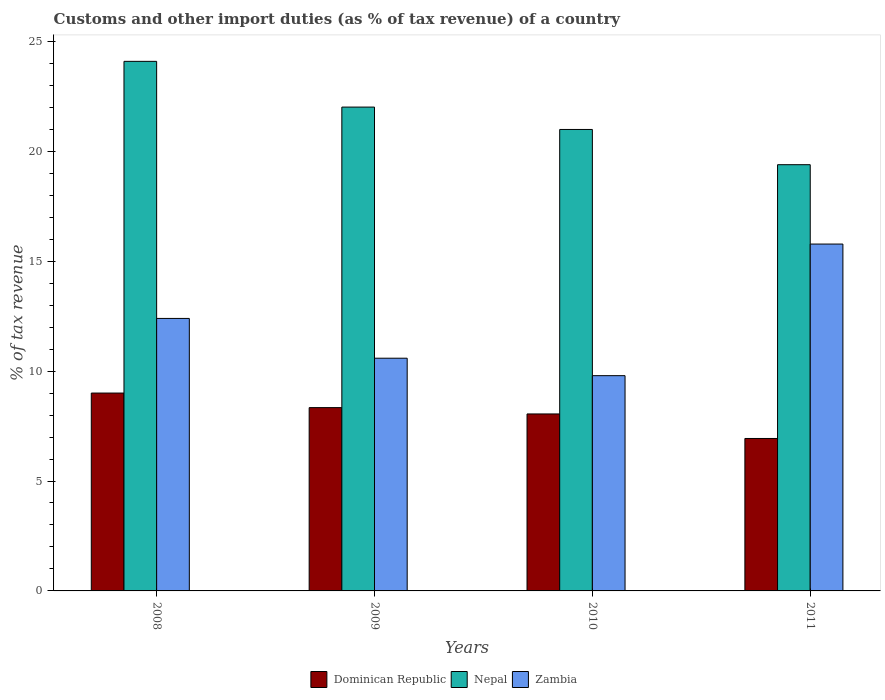How many different coloured bars are there?
Make the answer very short. 3. How many groups of bars are there?
Provide a succinct answer. 4. Are the number of bars per tick equal to the number of legend labels?
Keep it short and to the point. Yes. How many bars are there on the 1st tick from the right?
Provide a short and direct response. 3. What is the label of the 1st group of bars from the left?
Your answer should be compact. 2008. In how many cases, is the number of bars for a given year not equal to the number of legend labels?
Make the answer very short. 0. What is the percentage of tax revenue from customs in Zambia in 2009?
Give a very brief answer. 10.59. Across all years, what is the maximum percentage of tax revenue from customs in Zambia?
Your response must be concise. 15.78. Across all years, what is the minimum percentage of tax revenue from customs in Nepal?
Your answer should be compact. 19.39. In which year was the percentage of tax revenue from customs in Dominican Republic minimum?
Offer a terse response. 2011. What is the total percentage of tax revenue from customs in Nepal in the graph?
Provide a succinct answer. 86.49. What is the difference between the percentage of tax revenue from customs in Nepal in 2009 and that in 2010?
Your answer should be compact. 1.02. What is the difference between the percentage of tax revenue from customs in Zambia in 2011 and the percentage of tax revenue from customs in Dominican Republic in 2010?
Ensure brevity in your answer.  7.73. What is the average percentage of tax revenue from customs in Dominican Republic per year?
Your response must be concise. 8.08. In the year 2011, what is the difference between the percentage of tax revenue from customs in Zambia and percentage of tax revenue from customs in Nepal?
Offer a terse response. -3.61. In how many years, is the percentage of tax revenue from customs in Dominican Republic greater than 21 %?
Provide a short and direct response. 0. What is the ratio of the percentage of tax revenue from customs in Zambia in 2008 to that in 2009?
Your answer should be very brief. 1.17. Is the difference between the percentage of tax revenue from customs in Zambia in 2008 and 2010 greater than the difference between the percentage of tax revenue from customs in Nepal in 2008 and 2010?
Provide a succinct answer. No. What is the difference between the highest and the second highest percentage of tax revenue from customs in Dominican Republic?
Provide a short and direct response. 0.66. What is the difference between the highest and the lowest percentage of tax revenue from customs in Nepal?
Your response must be concise. 4.7. Is the sum of the percentage of tax revenue from customs in Zambia in 2009 and 2010 greater than the maximum percentage of tax revenue from customs in Dominican Republic across all years?
Make the answer very short. Yes. What does the 3rd bar from the left in 2009 represents?
Ensure brevity in your answer.  Zambia. What does the 3rd bar from the right in 2011 represents?
Offer a terse response. Dominican Republic. How many bars are there?
Your response must be concise. 12. Are all the bars in the graph horizontal?
Make the answer very short. No. What is the difference between two consecutive major ticks on the Y-axis?
Give a very brief answer. 5. Does the graph contain any zero values?
Offer a very short reply. No. Does the graph contain grids?
Keep it short and to the point. No. Where does the legend appear in the graph?
Ensure brevity in your answer.  Bottom center. How many legend labels are there?
Keep it short and to the point. 3. How are the legend labels stacked?
Your response must be concise. Horizontal. What is the title of the graph?
Keep it short and to the point. Customs and other import duties (as % of tax revenue) of a country. What is the label or title of the X-axis?
Your response must be concise. Years. What is the label or title of the Y-axis?
Offer a very short reply. % of tax revenue. What is the % of tax revenue of Dominican Republic in 2008?
Give a very brief answer. 9. What is the % of tax revenue in Nepal in 2008?
Ensure brevity in your answer.  24.09. What is the % of tax revenue in Zambia in 2008?
Offer a terse response. 12.4. What is the % of tax revenue of Dominican Republic in 2009?
Your response must be concise. 8.34. What is the % of tax revenue of Nepal in 2009?
Offer a terse response. 22.01. What is the % of tax revenue of Zambia in 2009?
Offer a very short reply. 10.59. What is the % of tax revenue in Dominican Republic in 2010?
Give a very brief answer. 8.05. What is the % of tax revenue of Nepal in 2010?
Offer a very short reply. 20.99. What is the % of tax revenue of Zambia in 2010?
Keep it short and to the point. 9.79. What is the % of tax revenue in Dominican Republic in 2011?
Provide a short and direct response. 6.94. What is the % of tax revenue in Nepal in 2011?
Give a very brief answer. 19.39. What is the % of tax revenue in Zambia in 2011?
Your response must be concise. 15.78. Across all years, what is the maximum % of tax revenue in Dominican Republic?
Your answer should be very brief. 9. Across all years, what is the maximum % of tax revenue in Nepal?
Your answer should be compact. 24.09. Across all years, what is the maximum % of tax revenue in Zambia?
Your response must be concise. 15.78. Across all years, what is the minimum % of tax revenue in Dominican Republic?
Your answer should be very brief. 6.94. Across all years, what is the minimum % of tax revenue in Nepal?
Make the answer very short. 19.39. Across all years, what is the minimum % of tax revenue of Zambia?
Offer a very short reply. 9.79. What is the total % of tax revenue in Dominican Republic in the graph?
Give a very brief answer. 32.33. What is the total % of tax revenue of Nepal in the graph?
Your answer should be very brief. 86.49. What is the total % of tax revenue of Zambia in the graph?
Your response must be concise. 48.56. What is the difference between the % of tax revenue of Dominican Republic in 2008 and that in 2009?
Keep it short and to the point. 0.66. What is the difference between the % of tax revenue in Nepal in 2008 and that in 2009?
Provide a short and direct response. 2.08. What is the difference between the % of tax revenue of Zambia in 2008 and that in 2009?
Make the answer very short. 1.81. What is the difference between the % of tax revenue of Dominican Republic in 2008 and that in 2010?
Keep it short and to the point. 0.95. What is the difference between the % of tax revenue of Nepal in 2008 and that in 2010?
Provide a succinct answer. 3.1. What is the difference between the % of tax revenue in Zambia in 2008 and that in 2010?
Give a very brief answer. 2.6. What is the difference between the % of tax revenue in Dominican Republic in 2008 and that in 2011?
Provide a succinct answer. 2.07. What is the difference between the % of tax revenue of Nepal in 2008 and that in 2011?
Provide a short and direct response. 4.7. What is the difference between the % of tax revenue of Zambia in 2008 and that in 2011?
Your answer should be very brief. -3.38. What is the difference between the % of tax revenue of Dominican Republic in 2009 and that in 2010?
Offer a very short reply. 0.29. What is the difference between the % of tax revenue of Nepal in 2009 and that in 2010?
Offer a very short reply. 1.02. What is the difference between the % of tax revenue of Zambia in 2009 and that in 2010?
Make the answer very short. 0.79. What is the difference between the % of tax revenue of Dominican Republic in 2009 and that in 2011?
Your answer should be very brief. 1.4. What is the difference between the % of tax revenue in Nepal in 2009 and that in 2011?
Provide a short and direct response. 2.62. What is the difference between the % of tax revenue in Zambia in 2009 and that in 2011?
Your response must be concise. -5.19. What is the difference between the % of tax revenue of Dominican Republic in 2010 and that in 2011?
Give a very brief answer. 1.12. What is the difference between the % of tax revenue in Nepal in 2010 and that in 2011?
Provide a short and direct response. 1.6. What is the difference between the % of tax revenue of Zambia in 2010 and that in 2011?
Your answer should be very brief. -5.99. What is the difference between the % of tax revenue of Dominican Republic in 2008 and the % of tax revenue of Nepal in 2009?
Offer a terse response. -13.01. What is the difference between the % of tax revenue of Dominican Republic in 2008 and the % of tax revenue of Zambia in 2009?
Offer a terse response. -1.58. What is the difference between the % of tax revenue in Nepal in 2008 and the % of tax revenue in Zambia in 2009?
Provide a succinct answer. 13.51. What is the difference between the % of tax revenue in Dominican Republic in 2008 and the % of tax revenue in Nepal in 2010?
Your response must be concise. -11.99. What is the difference between the % of tax revenue in Dominican Republic in 2008 and the % of tax revenue in Zambia in 2010?
Make the answer very short. -0.79. What is the difference between the % of tax revenue of Nepal in 2008 and the % of tax revenue of Zambia in 2010?
Keep it short and to the point. 14.3. What is the difference between the % of tax revenue in Dominican Republic in 2008 and the % of tax revenue in Nepal in 2011?
Your answer should be very brief. -10.39. What is the difference between the % of tax revenue in Dominican Republic in 2008 and the % of tax revenue in Zambia in 2011?
Your response must be concise. -6.78. What is the difference between the % of tax revenue of Nepal in 2008 and the % of tax revenue of Zambia in 2011?
Offer a very short reply. 8.31. What is the difference between the % of tax revenue of Dominican Republic in 2009 and the % of tax revenue of Nepal in 2010?
Provide a short and direct response. -12.65. What is the difference between the % of tax revenue in Dominican Republic in 2009 and the % of tax revenue in Zambia in 2010?
Offer a terse response. -1.45. What is the difference between the % of tax revenue in Nepal in 2009 and the % of tax revenue in Zambia in 2010?
Provide a short and direct response. 12.22. What is the difference between the % of tax revenue of Dominican Republic in 2009 and the % of tax revenue of Nepal in 2011?
Provide a short and direct response. -11.05. What is the difference between the % of tax revenue of Dominican Republic in 2009 and the % of tax revenue of Zambia in 2011?
Your answer should be compact. -7.44. What is the difference between the % of tax revenue in Nepal in 2009 and the % of tax revenue in Zambia in 2011?
Your response must be concise. 6.23. What is the difference between the % of tax revenue of Dominican Republic in 2010 and the % of tax revenue of Nepal in 2011?
Provide a short and direct response. -11.34. What is the difference between the % of tax revenue in Dominican Republic in 2010 and the % of tax revenue in Zambia in 2011?
Offer a terse response. -7.73. What is the difference between the % of tax revenue in Nepal in 2010 and the % of tax revenue in Zambia in 2011?
Provide a short and direct response. 5.21. What is the average % of tax revenue in Dominican Republic per year?
Your response must be concise. 8.08. What is the average % of tax revenue of Nepal per year?
Your response must be concise. 21.62. What is the average % of tax revenue of Zambia per year?
Keep it short and to the point. 12.14. In the year 2008, what is the difference between the % of tax revenue in Dominican Republic and % of tax revenue in Nepal?
Provide a succinct answer. -15.09. In the year 2008, what is the difference between the % of tax revenue of Dominican Republic and % of tax revenue of Zambia?
Your answer should be compact. -3.39. In the year 2008, what is the difference between the % of tax revenue in Nepal and % of tax revenue in Zambia?
Provide a succinct answer. 11.7. In the year 2009, what is the difference between the % of tax revenue of Dominican Republic and % of tax revenue of Nepal?
Your response must be concise. -13.67. In the year 2009, what is the difference between the % of tax revenue of Dominican Republic and % of tax revenue of Zambia?
Ensure brevity in your answer.  -2.25. In the year 2009, what is the difference between the % of tax revenue in Nepal and % of tax revenue in Zambia?
Provide a succinct answer. 11.43. In the year 2010, what is the difference between the % of tax revenue in Dominican Republic and % of tax revenue in Nepal?
Your answer should be compact. -12.94. In the year 2010, what is the difference between the % of tax revenue in Dominican Republic and % of tax revenue in Zambia?
Your response must be concise. -1.74. In the year 2010, what is the difference between the % of tax revenue of Nepal and % of tax revenue of Zambia?
Provide a succinct answer. 11.2. In the year 2011, what is the difference between the % of tax revenue in Dominican Republic and % of tax revenue in Nepal?
Offer a very short reply. -12.46. In the year 2011, what is the difference between the % of tax revenue in Dominican Republic and % of tax revenue in Zambia?
Offer a very short reply. -8.85. In the year 2011, what is the difference between the % of tax revenue of Nepal and % of tax revenue of Zambia?
Your answer should be very brief. 3.61. What is the ratio of the % of tax revenue in Dominican Republic in 2008 to that in 2009?
Ensure brevity in your answer.  1.08. What is the ratio of the % of tax revenue of Nepal in 2008 to that in 2009?
Your answer should be compact. 1.09. What is the ratio of the % of tax revenue of Zambia in 2008 to that in 2009?
Ensure brevity in your answer.  1.17. What is the ratio of the % of tax revenue in Dominican Republic in 2008 to that in 2010?
Your answer should be compact. 1.12. What is the ratio of the % of tax revenue in Nepal in 2008 to that in 2010?
Offer a terse response. 1.15. What is the ratio of the % of tax revenue of Zambia in 2008 to that in 2010?
Your answer should be compact. 1.27. What is the ratio of the % of tax revenue of Dominican Republic in 2008 to that in 2011?
Your answer should be compact. 1.3. What is the ratio of the % of tax revenue of Nepal in 2008 to that in 2011?
Keep it short and to the point. 1.24. What is the ratio of the % of tax revenue in Zambia in 2008 to that in 2011?
Your answer should be compact. 0.79. What is the ratio of the % of tax revenue in Dominican Republic in 2009 to that in 2010?
Offer a terse response. 1.04. What is the ratio of the % of tax revenue in Nepal in 2009 to that in 2010?
Offer a very short reply. 1.05. What is the ratio of the % of tax revenue in Zambia in 2009 to that in 2010?
Your response must be concise. 1.08. What is the ratio of the % of tax revenue of Dominican Republic in 2009 to that in 2011?
Make the answer very short. 1.2. What is the ratio of the % of tax revenue in Nepal in 2009 to that in 2011?
Your answer should be very brief. 1.14. What is the ratio of the % of tax revenue in Zambia in 2009 to that in 2011?
Your answer should be compact. 0.67. What is the ratio of the % of tax revenue of Dominican Republic in 2010 to that in 2011?
Give a very brief answer. 1.16. What is the ratio of the % of tax revenue of Nepal in 2010 to that in 2011?
Keep it short and to the point. 1.08. What is the ratio of the % of tax revenue in Zambia in 2010 to that in 2011?
Your answer should be very brief. 0.62. What is the difference between the highest and the second highest % of tax revenue of Dominican Republic?
Make the answer very short. 0.66. What is the difference between the highest and the second highest % of tax revenue in Nepal?
Your response must be concise. 2.08. What is the difference between the highest and the second highest % of tax revenue in Zambia?
Give a very brief answer. 3.38. What is the difference between the highest and the lowest % of tax revenue of Dominican Republic?
Your answer should be very brief. 2.07. What is the difference between the highest and the lowest % of tax revenue of Nepal?
Your response must be concise. 4.7. What is the difference between the highest and the lowest % of tax revenue of Zambia?
Ensure brevity in your answer.  5.99. 